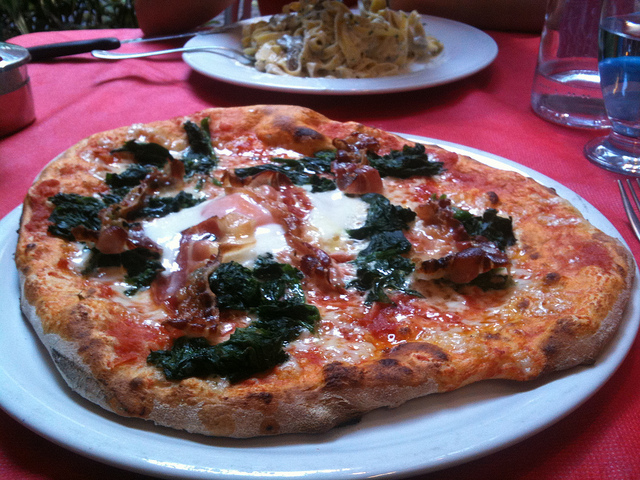<image>What is the table made of? I am not sure what the table is made of. It could be wood. What type of vegetable is next to the pizza? I don't know what type of vegetable is next to the pizza. It could possibly be spinach. What is the table made of? I don't know what the table is made of. It looks like it could be made of wood. What type of vegetable is next to the pizza? I don't know what type of vegetable is next to the pizza. It can be spinach. 